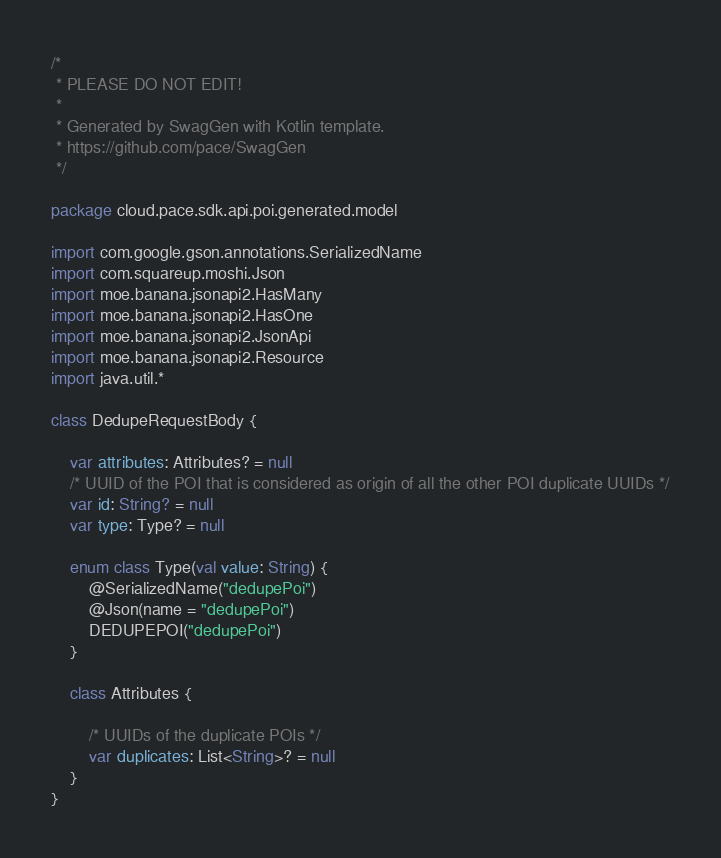Convert code to text. <code><loc_0><loc_0><loc_500><loc_500><_Kotlin_>/*
 * PLEASE DO NOT EDIT!
 *
 * Generated by SwagGen with Kotlin template.
 * https://github.com/pace/SwagGen
 */

package cloud.pace.sdk.api.poi.generated.model

import com.google.gson.annotations.SerializedName
import com.squareup.moshi.Json
import moe.banana.jsonapi2.HasMany
import moe.banana.jsonapi2.HasOne
import moe.banana.jsonapi2.JsonApi
import moe.banana.jsonapi2.Resource
import java.util.*

class DedupeRequestBody {

    var attributes: Attributes? = null
    /* UUID of the POI that is considered as origin of all the other POI duplicate UUIDs */
    var id: String? = null
    var type: Type? = null

    enum class Type(val value: String) {
        @SerializedName("dedupePoi")
        @Json(name = "dedupePoi")
        DEDUPEPOI("dedupePoi")
    }

    class Attributes {

        /* UUIDs of the duplicate POIs */
        var duplicates: List<String>? = null
    }
}
</code> 